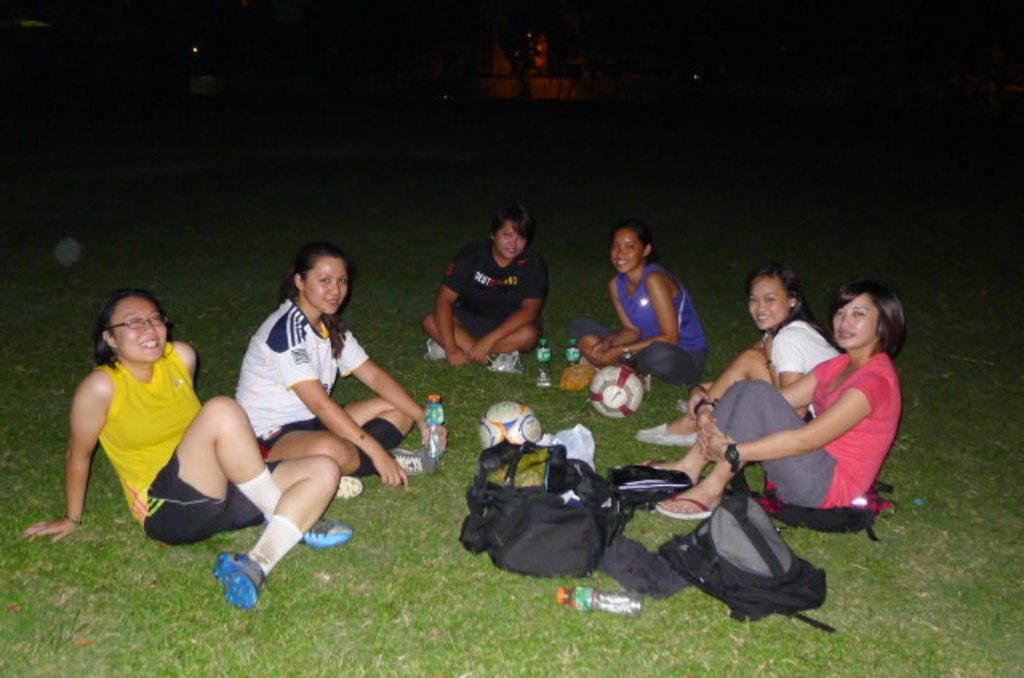What are the ladies in the image doing? The ladies in the image are sitting on the ground. What type of surface are they sitting on? There is grass on the ground where they are sitting. What objects can be seen in the image besides the ladies? There are bottles, balls, and bags in the image. Can you describe the background of the image? The background of the image is dark. Can you see any bubbles floating around the ladies in the image? There are no bubbles visible in the image. Is there a grandmother sitting with the ladies in the image? There is no mention of a grandmother in the image, only ladies are mentioned. Are there any rabbits present in the image? There is no mention of a rabbit in the image. 